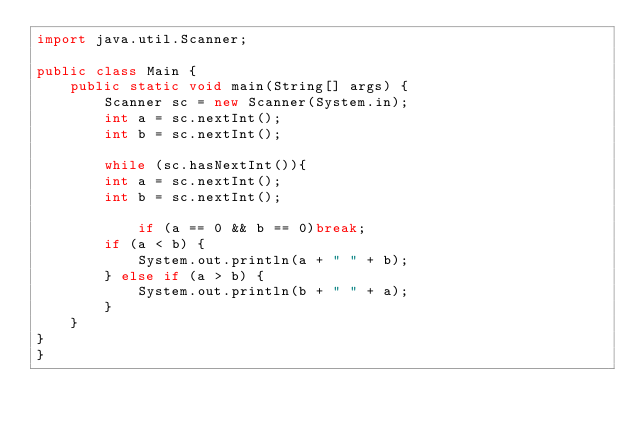Convert code to text. <code><loc_0><loc_0><loc_500><loc_500><_Java_>import java.util.Scanner;

public class Main {
	public static void main(String[] args) {
		Scanner sc = new Scanner(System.in);
		int a = sc.nextInt();
		int b = sc.nextInt();

		while (sc.hasNextInt()){
		int a = sc.nextInt();
		int b = sc.nextInt();

			if (a == 0 && b == 0)break;
		if (a < b) {
			System.out.println(a + " " + b);
		} else if (a > b) {
			System.out.println(b + " " + a);
		}
	}
}
}
</code> 